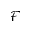<formula> <loc_0><loc_0><loc_500><loc_500>\mathcal { F }</formula> 